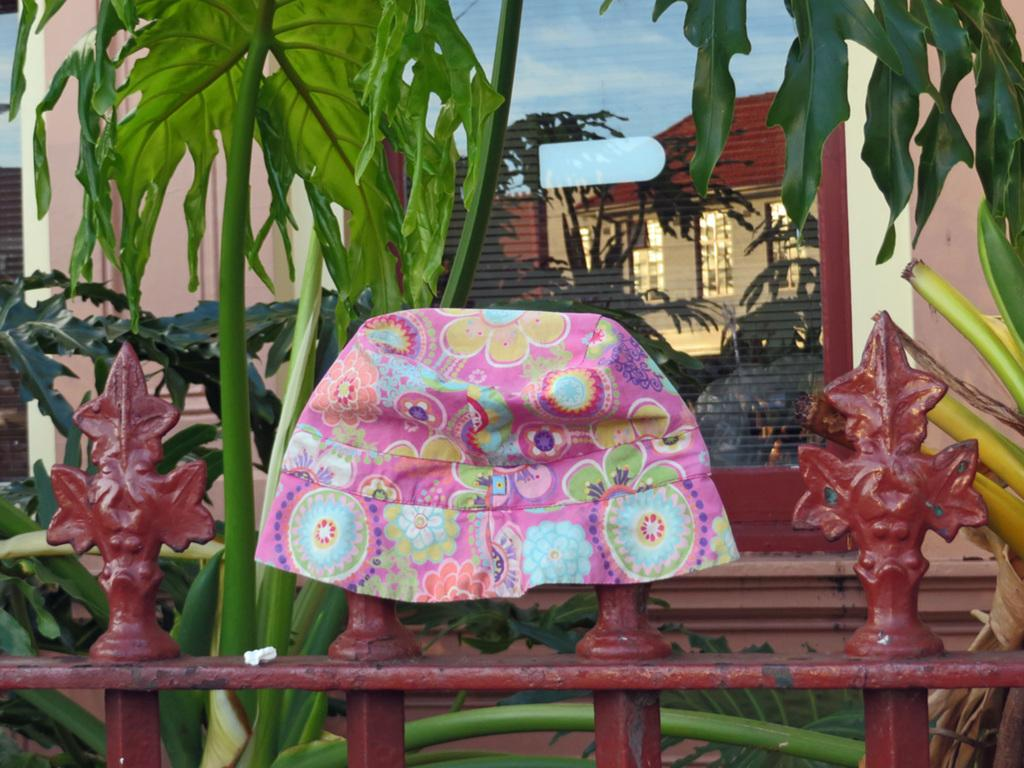What object is placed on the fence in the foreground of the image? There is a cap placed on the fence in the foreground of the image. What can be seen in the background of the image? There is a group of trees and a building with windows in the background of the image. What feature of the building is visible in the image? There is a door associated with the building in the background of the image. What type of drink is being shared between friends in the image? There is no drink or friends present in the image; it only features a cap on a fence, trees, and a building in the background. 